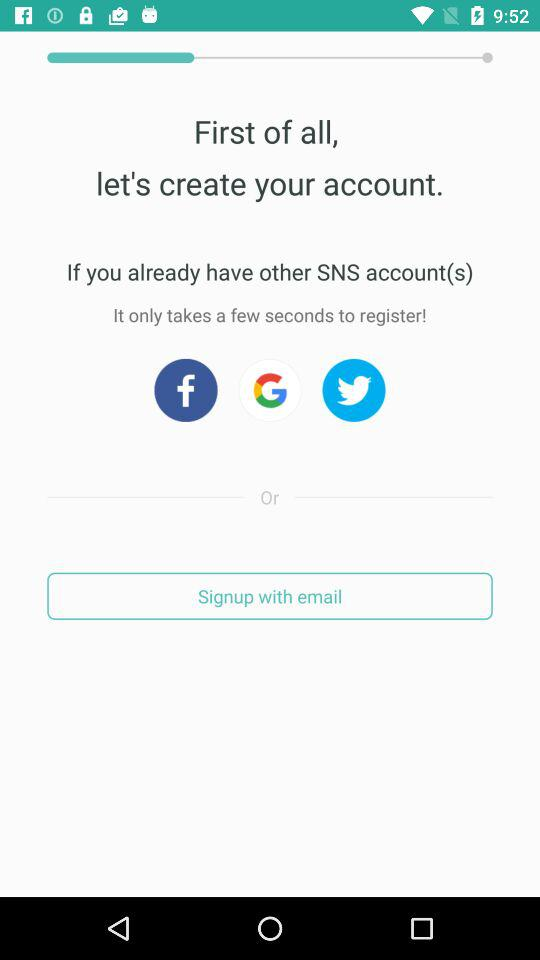What are the different login options? The different login options are "Facebook", "Google", "Twitter" and "email". 